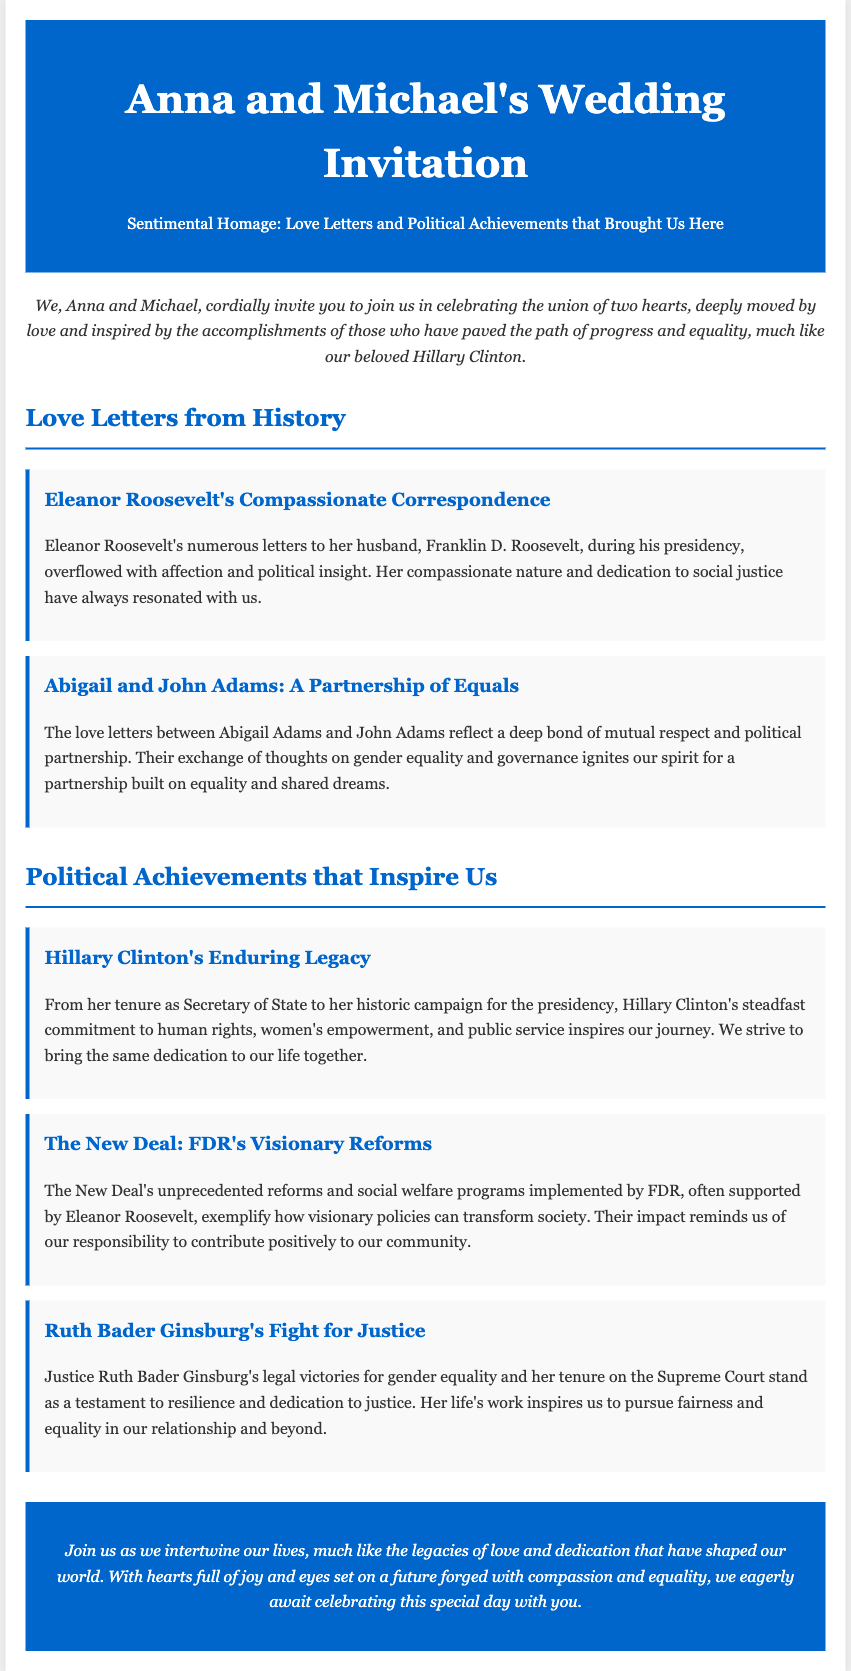What is the name of the couple getting married? The names of the couple getting married are mentioned in the header section of the document.
Answer: Anna and Michael What historical figure's letters inspired Anna and Michael? The document highlights letters from historical figures that served as inspiration, specifically mentioned in the section headers.
Answer: Eleanor Roosevelt What is the main theme of the wedding invitation? The invitation outlines its theme in the introductory paragraph, emphasizing the significance of love and historical political achievements.
Answer: Sentimental Homage Which political figure's legacy is celebrated in the invitation? The document specifically mentions a prominent political figure whose contributions are recognized and celebrated, particularly in the achievements section.
Answer: Hillary Clinton How many love letters are mentioned in the document? The document contains a list of specific love letters and highlights two prominent historical couples.
Answer: Two What is the color of the header background? The style defined in the header includes a background color, which is consistent throughout the document.
Answer: #0066cc Which justice’s fight for equality is referenced? The invitation recognizes a notable figure in the field of law and equality in the achievements section.
Answer: Ruth Bader Ginsburg What is the format of the wedding invitation? The structure and overall format of this document as a wedding invitation includes specific sections detailing love letters and political achievements.
Answer: HTML Document What are Anna and Michael's aspirations for their marriage? The footer outlines their hopes and aspirations as they join their lives together, reflecting on values inspired by others.
Answer: Compassion and equality 